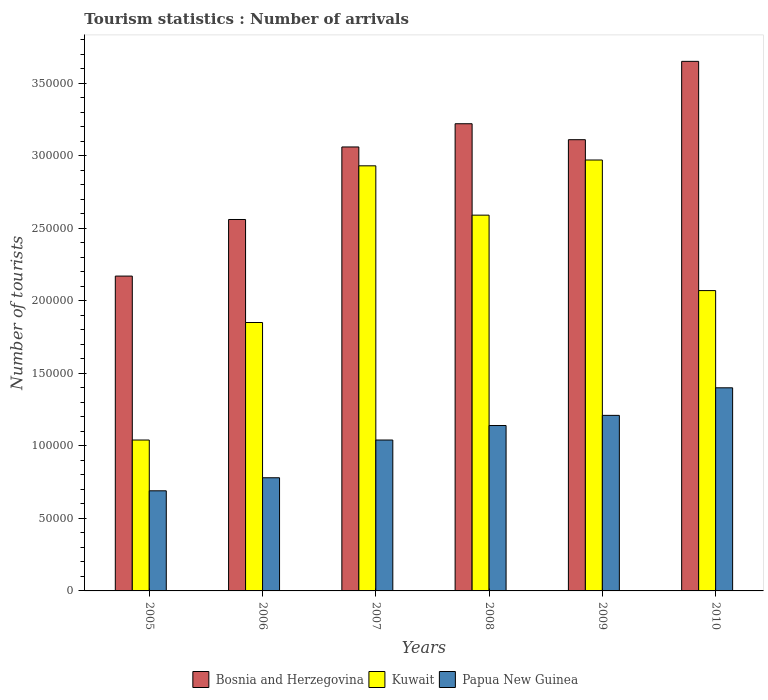How many different coloured bars are there?
Make the answer very short. 3. Are the number of bars on each tick of the X-axis equal?
Keep it short and to the point. Yes. How many bars are there on the 2nd tick from the right?
Make the answer very short. 3. What is the label of the 3rd group of bars from the left?
Ensure brevity in your answer.  2007. What is the number of tourist arrivals in Papua New Guinea in 2005?
Provide a succinct answer. 6.90e+04. Across all years, what is the maximum number of tourist arrivals in Bosnia and Herzegovina?
Offer a terse response. 3.65e+05. Across all years, what is the minimum number of tourist arrivals in Papua New Guinea?
Your answer should be very brief. 6.90e+04. In which year was the number of tourist arrivals in Kuwait maximum?
Ensure brevity in your answer.  2009. What is the total number of tourist arrivals in Kuwait in the graph?
Offer a terse response. 1.34e+06. What is the difference between the number of tourist arrivals in Bosnia and Herzegovina in 2005 and that in 2010?
Keep it short and to the point. -1.48e+05. What is the difference between the number of tourist arrivals in Papua New Guinea in 2008 and the number of tourist arrivals in Bosnia and Herzegovina in 2010?
Offer a terse response. -2.51e+05. What is the average number of tourist arrivals in Bosnia and Herzegovina per year?
Give a very brief answer. 2.96e+05. In the year 2010, what is the difference between the number of tourist arrivals in Bosnia and Herzegovina and number of tourist arrivals in Papua New Guinea?
Keep it short and to the point. 2.25e+05. In how many years, is the number of tourist arrivals in Papua New Guinea greater than 260000?
Offer a terse response. 0. What is the ratio of the number of tourist arrivals in Kuwait in 2006 to that in 2009?
Provide a succinct answer. 0.62. Is the number of tourist arrivals in Papua New Guinea in 2005 less than that in 2010?
Provide a succinct answer. Yes. What is the difference between the highest and the second highest number of tourist arrivals in Kuwait?
Make the answer very short. 4000. What is the difference between the highest and the lowest number of tourist arrivals in Papua New Guinea?
Give a very brief answer. 7.10e+04. In how many years, is the number of tourist arrivals in Papua New Guinea greater than the average number of tourist arrivals in Papua New Guinea taken over all years?
Provide a short and direct response. 3. Is the sum of the number of tourist arrivals in Papua New Guinea in 2007 and 2009 greater than the maximum number of tourist arrivals in Kuwait across all years?
Provide a short and direct response. No. What does the 3rd bar from the left in 2005 represents?
Provide a succinct answer. Papua New Guinea. What does the 2nd bar from the right in 2009 represents?
Keep it short and to the point. Kuwait. Is it the case that in every year, the sum of the number of tourist arrivals in Kuwait and number of tourist arrivals in Bosnia and Herzegovina is greater than the number of tourist arrivals in Papua New Guinea?
Offer a very short reply. Yes. Are all the bars in the graph horizontal?
Your response must be concise. No. How many years are there in the graph?
Offer a very short reply. 6. Does the graph contain any zero values?
Your answer should be compact. No. Does the graph contain grids?
Your answer should be compact. No. How many legend labels are there?
Make the answer very short. 3. How are the legend labels stacked?
Give a very brief answer. Horizontal. What is the title of the graph?
Your answer should be very brief. Tourism statistics : Number of arrivals. What is the label or title of the Y-axis?
Keep it short and to the point. Number of tourists. What is the Number of tourists in Bosnia and Herzegovina in 2005?
Ensure brevity in your answer.  2.17e+05. What is the Number of tourists of Kuwait in 2005?
Make the answer very short. 1.04e+05. What is the Number of tourists in Papua New Guinea in 2005?
Offer a very short reply. 6.90e+04. What is the Number of tourists of Bosnia and Herzegovina in 2006?
Offer a very short reply. 2.56e+05. What is the Number of tourists in Kuwait in 2006?
Offer a very short reply. 1.85e+05. What is the Number of tourists in Papua New Guinea in 2006?
Offer a very short reply. 7.80e+04. What is the Number of tourists of Bosnia and Herzegovina in 2007?
Keep it short and to the point. 3.06e+05. What is the Number of tourists of Kuwait in 2007?
Your answer should be compact. 2.93e+05. What is the Number of tourists of Papua New Guinea in 2007?
Your response must be concise. 1.04e+05. What is the Number of tourists in Bosnia and Herzegovina in 2008?
Make the answer very short. 3.22e+05. What is the Number of tourists of Kuwait in 2008?
Keep it short and to the point. 2.59e+05. What is the Number of tourists in Papua New Guinea in 2008?
Your response must be concise. 1.14e+05. What is the Number of tourists in Bosnia and Herzegovina in 2009?
Your answer should be compact. 3.11e+05. What is the Number of tourists of Kuwait in 2009?
Make the answer very short. 2.97e+05. What is the Number of tourists of Papua New Guinea in 2009?
Give a very brief answer. 1.21e+05. What is the Number of tourists in Bosnia and Herzegovina in 2010?
Ensure brevity in your answer.  3.65e+05. What is the Number of tourists in Kuwait in 2010?
Your answer should be very brief. 2.07e+05. Across all years, what is the maximum Number of tourists of Bosnia and Herzegovina?
Your answer should be compact. 3.65e+05. Across all years, what is the maximum Number of tourists in Kuwait?
Offer a very short reply. 2.97e+05. Across all years, what is the minimum Number of tourists of Bosnia and Herzegovina?
Your answer should be very brief. 2.17e+05. Across all years, what is the minimum Number of tourists of Kuwait?
Your response must be concise. 1.04e+05. Across all years, what is the minimum Number of tourists of Papua New Guinea?
Keep it short and to the point. 6.90e+04. What is the total Number of tourists in Bosnia and Herzegovina in the graph?
Offer a very short reply. 1.78e+06. What is the total Number of tourists of Kuwait in the graph?
Your answer should be very brief. 1.34e+06. What is the total Number of tourists in Papua New Guinea in the graph?
Make the answer very short. 6.26e+05. What is the difference between the Number of tourists of Bosnia and Herzegovina in 2005 and that in 2006?
Offer a terse response. -3.90e+04. What is the difference between the Number of tourists in Kuwait in 2005 and that in 2006?
Keep it short and to the point. -8.10e+04. What is the difference between the Number of tourists of Papua New Guinea in 2005 and that in 2006?
Give a very brief answer. -9000. What is the difference between the Number of tourists in Bosnia and Herzegovina in 2005 and that in 2007?
Ensure brevity in your answer.  -8.90e+04. What is the difference between the Number of tourists of Kuwait in 2005 and that in 2007?
Provide a short and direct response. -1.89e+05. What is the difference between the Number of tourists of Papua New Guinea in 2005 and that in 2007?
Ensure brevity in your answer.  -3.50e+04. What is the difference between the Number of tourists in Bosnia and Herzegovina in 2005 and that in 2008?
Provide a short and direct response. -1.05e+05. What is the difference between the Number of tourists of Kuwait in 2005 and that in 2008?
Give a very brief answer. -1.55e+05. What is the difference between the Number of tourists of Papua New Guinea in 2005 and that in 2008?
Offer a very short reply. -4.50e+04. What is the difference between the Number of tourists of Bosnia and Herzegovina in 2005 and that in 2009?
Ensure brevity in your answer.  -9.40e+04. What is the difference between the Number of tourists of Kuwait in 2005 and that in 2009?
Provide a succinct answer. -1.93e+05. What is the difference between the Number of tourists in Papua New Guinea in 2005 and that in 2009?
Give a very brief answer. -5.20e+04. What is the difference between the Number of tourists of Bosnia and Herzegovina in 2005 and that in 2010?
Your response must be concise. -1.48e+05. What is the difference between the Number of tourists in Kuwait in 2005 and that in 2010?
Keep it short and to the point. -1.03e+05. What is the difference between the Number of tourists in Papua New Guinea in 2005 and that in 2010?
Your response must be concise. -7.10e+04. What is the difference between the Number of tourists of Kuwait in 2006 and that in 2007?
Offer a terse response. -1.08e+05. What is the difference between the Number of tourists of Papua New Guinea in 2006 and that in 2007?
Make the answer very short. -2.60e+04. What is the difference between the Number of tourists of Bosnia and Herzegovina in 2006 and that in 2008?
Provide a succinct answer. -6.60e+04. What is the difference between the Number of tourists in Kuwait in 2006 and that in 2008?
Offer a very short reply. -7.40e+04. What is the difference between the Number of tourists in Papua New Guinea in 2006 and that in 2008?
Give a very brief answer. -3.60e+04. What is the difference between the Number of tourists of Bosnia and Herzegovina in 2006 and that in 2009?
Your response must be concise. -5.50e+04. What is the difference between the Number of tourists in Kuwait in 2006 and that in 2009?
Offer a very short reply. -1.12e+05. What is the difference between the Number of tourists of Papua New Guinea in 2006 and that in 2009?
Your response must be concise. -4.30e+04. What is the difference between the Number of tourists of Bosnia and Herzegovina in 2006 and that in 2010?
Give a very brief answer. -1.09e+05. What is the difference between the Number of tourists in Kuwait in 2006 and that in 2010?
Ensure brevity in your answer.  -2.20e+04. What is the difference between the Number of tourists in Papua New Guinea in 2006 and that in 2010?
Keep it short and to the point. -6.20e+04. What is the difference between the Number of tourists of Bosnia and Herzegovina in 2007 and that in 2008?
Ensure brevity in your answer.  -1.60e+04. What is the difference between the Number of tourists of Kuwait in 2007 and that in 2008?
Make the answer very short. 3.40e+04. What is the difference between the Number of tourists in Papua New Guinea in 2007 and that in 2008?
Your response must be concise. -10000. What is the difference between the Number of tourists of Bosnia and Herzegovina in 2007 and that in 2009?
Make the answer very short. -5000. What is the difference between the Number of tourists of Kuwait in 2007 and that in 2009?
Your response must be concise. -4000. What is the difference between the Number of tourists in Papua New Guinea in 2007 and that in 2009?
Offer a terse response. -1.70e+04. What is the difference between the Number of tourists of Bosnia and Herzegovina in 2007 and that in 2010?
Your answer should be compact. -5.90e+04. What is the difference between the Number of tourists in Kuwait in 2007 and that in 2010?
Make the answer very short. 8.60e+04. What is the difference between the Number of tourists in Papua New Guinea in 2007 and that in 2010?
Offer a very short reply. -3.60e+04. What is the difference between the Number of tourists in Bosnia and Herzegovina in 2008 and that in 2009?
Your answer should be very brief. 1.10e+04. What is the difference between the Number of tourists of Kuwait in 2008 and that in 2009?
Ensure brevity in your answer.  -3.80e+04. What is the difference between the Number of tourists in Papua New Guinea in 2008 and that in 2009?
Offer a terse response. -7000. What is the difference between the Number of tourists of Bosnia and Herzegovina in 2008 and that in 2010?
Your response must be concise. -4.30e+04. What is the difference between the Number of tourists of Kuwait in 2008 and that in 2010?
Provide a short and direct response. 5.20e+04. What is the difference between the Number of tourists of Papua New Guinea in 2008 and that in 2010?
Keep it short and to the point. -2.60e+04. What is the difference between the Number of tourists of Bosnia and Herzegovina in 2009 and that in 2010?
Your response must be concise. -5.40e+04. What is the difference between the Number of tourists in Kuwait in 2009 and that in 2010?
Give a very brief answer. 9.00e+04. What is the difference between the Number of tourists in Papua New Guinea in 2009 and that in 2010?
Make the answer very short. -1.90e+04. What is the difference between the Number of tourists in Bosnia and Herzegovina in 2005 and the Number of tourists in Kuwait in 2006?
Your response must be concise. 3.20e+04. What is the difference between the Number of tourists of Bosnia and Herzegovina in 2005 and the Number of tourists of Papua New Guinea in 2006?
Provide a succinct answer. 1.39e+05. What is the difference between the Number of tourists in Kuwait in 2005 and the Number of tourists in Papua New Guinea in 2006?
Your answer should be very brief. 2.60e+04. What is the difference between the Number of tourists of Bosnia and Herzegovina in 2005 and the Number of tourists of Kuwait in 2007?
Ensure brevity in your answer.  -7.60e+04. What is the difference between the Number of tourists of Bosnia and Herzegovina in 2005 and the Number of tourists of Papua New Guinea in 2007?
Offer a terse response. 1.13e+05. What is the difference between the Number of tourists in Bosnia and Herzegovina in 2005 and the Number of tourists in Kuwait in 2008?
Keep it short and to the point. -4.20e+04. What is the difference between the Number of tourists in Bosnia and Herzegovina in 2005 and the Number of tourists in Papua New Guinea in 2008?
Your answer should be very brief. 1.03e+05. What is the difference between the Number of tourists in Kuwait in 2005 and the Number of tourists in Papua New Guinea in 2008?
Your answer should be very brief. -10000. What is the difference between the Number of tourists of Bosnia and Herzegovina in 2005 and the Number of tourists of Papua New Guinea in 2009?
Your answer should be compact. 9.60e+04. What is the difference between the Number of tourists in Kuwait in 2005 and the Number of tourists in Papua New Guinea in 2009?
Your answer should be very brief. -1.70e+04. What is the difference between the Number of tourists in Bosnia and Herzegovina in 2005 and the Number of tourists in Kuwait in 2010?
Your answer should be very brief. 10000. What is the difference between the Number of tourists in Bosnia and Herzegovina in 2005 and the Number of tourists in Papua New Guinea in 2010?
Your response must be concise. 7.70e+04. What is the difference between the Number of tourists in Kuwait in 2005 and the Number of tourists in Papua New Guinea in 2010?
Your answer should be very brief. -3.60e+04. What is the difference between the Number of tourists of Bosnia and Herzegovina in 2006 and the Number of tourists of Kuwait in 2007?
Provide a short and direct response. -3.70e+04. What is the difference between the Number of tourists of Bosnia and Herzegovina in 2006 and the Number of tourists of Papua New Guinea in 2007?
Offer a terse response. 1.52e+05. What is the difference between the Number of tourists in Kuwait in 2006 and the Number of tourists in Papua New Guinea in 2007?
Your response must be concise. 8.10e+04. What is the difference between the Number of tourists in Bosnia and Herzegovina in 2006 and the Number of tourists in Kuwait in 2008?
Your answer should be very brief. -3000. What is the difference between the Number of tourists of Bosnia and Herzegovina in 2006 and the Number of tourists of Papua New Guinea in 2008?
Make the answer very short. 1.42e+05. What is the difference between the Number of tourists in Kuwait in 2006 and the Number of tourists in Papua New Guinea in 2008?
Give a very brief answer. 7.10e+04. What is the difference between the Number of tourists in Bosnia and Herzegovina in 2006 and the Number of tourists in Kuwait in 2009?
Keep it short and to the point. -4.10e+04. What is the difference between the Number of tourists of Bosnia and Herzegovina in 2006 and the Number of tourists of Papua New Guinea in 2009?
Give a very brief answer. 1.35e+05. What is the difference between the Number of tourists in Kuwait in 2006 and the Number of tourists in Papua New Guinea in 2009?
Offer a very short reply. 6.40e+04. What is the difference between the Number of tourists in Bosnia and Herzegovina in 2006 and the Number of tourists in Kuwait in 2010?
Your response must be concise. 4.90e+04. What is the difference between the Number of tourists in Bosnia and Herzegovina in 2006 and the Number of tourists in Papua New Guinea in 2010?
Provide a succinct answer. 1.16e+05. What is the difference between the Number of tourists in Kuwait in 2006 and the Number of tourists in Papua New Guinea in 2010?
Give a very brief answer. 4.50e+04. What is the difference between the Number of tourists in Bosnia and Herzegovina in 2007 and the Number of tourists in Kuwait in 2008?
Keep it short and to the point. 4.70e+04. What is the difference between the Number of tourists in Bosnia and Herzegovina in 2007 and the Number of tourists in Papua New Guinea in 2008?
Keep it short and to the point. 1.92e+05. What is the difference between the Number of tourists of Kuwait in 2007 and the Number of tourists of Papua New Guinea in 2008?
Your response must be concise. 1.79e+05. What is the difference between the Number of tourists in Bosnia and Herzegovina in 2007 and the Number of tourists in Kuwait in 2009?
Offer a very short reply. 9000. What is the difference between the Number of tourists in Bosnia and Herzegovina in 2007 and the Number of tourists in Papua New Guinea in 2009?
Your answer should be very brief. 1.85e+05. What is the difference between the Number of tourists in Kuwait in 2007 and the Number of tourists in Papua New Guinea in 2009?
Give a very brief answer. 1.72e+05. What is the difference between the Number of tourists in Bosnia and Herzegovina in 2007 and the Number of tourists in Kuwait in 2010?
Offer a very short reply. 9.90e+04. What is the difference between the Number of tourists of Bosnia and Herzegovina in 2007 and the Number of tourists of Papua New Guinea in 2010?
Provide a succinct answer. 1.66e+05. What is the difference between the Number of tourists in Kuwait in 2007 and the Number of tourists in Papua New Guinea in 2010?
Ensure brevity in your answer.  1.53e+05. What is the difference between the Number of tourists in Bosnia and Herzegovina in 2008 and the Number of tourists in Kuwait in 2009?
Ensure brevity in your answer.  2.50e+04. What is the difference between the Number of tourists of Bosnia and Herzegovina in 2008 and the Number of tourists of Papua New Guinea in 2009?
Give a very brief answer. 2.01e+05. What is the difference between the Number of tourists of Kuwait in 2008 and the Number of tourists of Papua New Guinea in 2009?
Your answer should be very brief. 1.38e+05. What is the difference between the Number of tourists in Bosnia and Herzegovina in 2008 and the Number of tourists in Kuwait in 2010?
Ensure brevity in your answer.  1.15e+05. What is the difference between the Number of tourists of Bosnia and Herzegovina in 2008 and the Number of tourists of Papua New Guinea in 2010?
Give a very brief answer. 1.82e+05. What is the difference between the Number of tourists in Kuwait in 2008 and the Number of tourists in Papua New Guinea in 2010?
Ensure brevity in your answer.  1.19e+05. What is the difference between the Number of tourists of Bosnia and Herzegovina in 2009 and the Number of tourists of Kuwait in 2010?
Provide a succinct answer. 1.04e+05. What is the difference between the Number of tourists of Bosnia and Herzegovina in 2009 and the Number of tourists of Papua New Guinea in 2010?
Your answer should be very brief. 1.71e+05. What is the difference between the Number of tourists in Kuwait in 2009 and the Number of tourists in Papua New Guinea in 2010?
Ensure brevity in your answer.  1.57e+05. What is the average Number of tourists of Bosnia and Herzegovina per year?
Your response must be concise. 2.96e+05. What is the average Number of tourists in Kuwait per year?
Your response must be concise. 2.24e+05. What is the average Number of tourists of Papua New Guinea per year?
Your answer should be very brief. 1.04e+05. In the year 2005, what is the difference between the Number of tourists in Bosnia and Herzegovina and Number of tourists in Kuwait?
Provide a succinct answer. 1.13e+05. In the year 2005, what is the difference between the Number of tourists in Bosnia and Herzegovina and Number of tourists in Papua New Guinea?
Your answer should be compact. 1.48e+05. In the year 2005, what is the difference between the Number of tourists in Kuwait and Number of tourists in Papua New Guinea?
Provide a succinct answer. 3.50e+04. In the year 2006, what is the difference between the Number of tourists of Bosnia and Herzegovina and Number of tourists of Kuwait?
Ensure brevity in your answer.  7.10e+04. In the year 2006, what is the difference between the Number of tourists in Bosnia and Herzegovina and Number of tourists in Papua New Guinea?
Give a very brief answer. 1.78e+05. In the year 2006, what is the difference between the Number of tourists in Kuwait and Number of tourists in Papua New Guinea?
Provide a succinct answer. 1.07e+05. In the year 2007, what is the difference between the Number of tourists in Bosnia and Herzegovina and Number of tourists in Kuwait?
Provide a succinct answer. 1.30e+04. In the year 2007, what is the difference between the Number of tourists in Bosnia and Herzegovina and Number of tourists in Papua New Guinea?
Provide a succinct answer. 2.02e+05. In the year 2007, what is the difference between the Number of tourists in Kuwait and Number of tourists in Papua New Guinea?
Offer a very short reply. 1.89e+05. In the year 2008, what is the difference between the Number of tourists in Bosnia and Herzegovina and Number of tourists in Kuwait?
Your response must be concise. 6.30e+04. In the year 2008, what is the difference between the Number of tourists of Bosnia and Herzegovina and Number of tourists of Papua New Guinea?
Offer a very short reply. 2.08e+05. In the year 2008, what is the difference between the Number of tourists of Kuwait and Number of tourists of Papua New Guinea?
Give a very brief answer. 1.45e+05. In the year 2009, what is the difference between the Number of tourists in Bosnia and Herzegovina and Number of tourists in Kuwait?
Give a very brief answer. 1.40e+04. In the year 2009, what is the difference between the Number of tourists in Bosnia and Herzegovina and Number of tourists in Papua New Guinea?
Provide a succinct answer. 1.90e+05. In the year 2009, what is the difference between the Number of tourists of Kuwait and Number of tourists of Papua New Guinea?
Offer a very short reply. 1.76e+05. In the year 2010, what is the difference between the Number of tourists of Bosnia and Herzegovina and Number of tourists of Kuwait?
Give a very brief answer. 1.58e+05. In the year 2010, what is the difference between the Number of tourists of Bosnia and Herzegovina and Number of tourists of Papua New Guinea?
Make the answer very short. 2.25e+05. In the year 2010, what is the difference between the Number of tourists in Kuwait and Number of tourists in Papua New Guinea?
Ensure brevity in your answer.  6.70e+04. What is the ratio of the Number of tourists of Bosnia and Herzegovina in 2005 to that in 2006?
Keep it short and to the point. 0.85. What is the ratio of the Number of tourists in Kuwait in 2005 to that in 2006?
Provide a succinct answer. 0.56. What is the ratio of the Number of tourists of Papua New Guinea in 2005 to that in 2006?
Ensure brevity in your answer.  0.88. What is the ratio of the Number of tourists in Bosnia and Herzegovina in 2005 to that in 2007?
Your response must be concise. 0.71. What is the ratio of the Number of tourists in Kuwait in 2005 to that in 2007?
Your response must be concise. 0.35. What is the ratio of the Number of tourists of Papua New Guinea in 2005 to that in 2007?
Provide a short and direct response. 0.66. What is the ratio of the Number of tourists of Bosnia and Herzegovina in 2005 to that in 2008?
Make the answer very short. 0.67. What is the ratio of the Number of tourists in Kuwait in 2005 to that in 2008?
Offer a terse response. 0.4. What is the ratio of the Number of tourists of Papua New Guinea in 2005 to that in 2008?
Your answer should be very brief. 0.61. What is the ratio of the Number of tourists in Bosnia and Herzegovina in 2005 to that in 2009?
Make the answer very short. 0.7. What is the ratio of the Number of tourists in Kuwait in 2005 to that in 2009?
Offer a terse response. 0.35. What is the ratio of the Number of tourists of Papua New Guinea in 2005 to that in 2009?
Provide a short and direct response. 0.57. What is the ratio of the Number of tourists in Bosnia and Herzegovina in 2005 to that in 2010?
Provide a short and direct response. 0.59. What is the ratio of the Number of tourists of Kuwait in 2005 to that in 2010?
Your response must be concise. 0.5. What is the ratio of the Number of tourists in Papua New Guinea in 2005 to that in 2010?
Provide a short and direct response. 0.49. What is the ratio of the Number of tourists of Bosnia and Herzegovina in 2006 to that in 2007?
Provide a succinct answer. 0.84. What is the ratio of the Number of tourists in Kuwait in 2006 to that in 2007?
Provide a succinct answer. 0.63. What is the ratio of the Number of tourists in Papua New Guinea in 2006 to that in 2007?
Offer a very short reply. 0.75. What is the ratio of the Number of tourists in Bosnia and Herzegovina in 2006 to that in 2008?
Offer a very short reply. 0.8. What is the ratio of the Number of tourists of Papua New Guinea in 2006 to that in 2008?
Give a very brief answer. 0.68. What is the ratio of the Number of tourists of Bosnia and Herzegovina in 2006 to that in 2009?
Your answer should be compact. 0.82. What is the ratio of the Number of tourists in Kuwait in 2006 to that in 2009?
Offer a terse response. 0.62. What is the ratio of the Number of tourists in Papua New Guinea in 2006 to that in 2009?
Your response must be concise. 0.64. What is the ratio of the Number of tourists in Bosnia and Herzegovina in 2006 to that in 2010?
Offer a terse response. 0.7. What is the ratio of the Number of tourists in Kuwait in 2006 to that in 2010?
Provide a short and direct response. 0.89. What is the ratio of the Number of tourists of Papua New Guinea in 2006 to that in 2010?
Your response must be concise. 0.56. What is the ratio of the Number of tourists in Bosnia and Herzegovina in 2007 to that in 2008?
Ensure brevity in your answer.  0.95. What is the ratio of the Number of tourists of Kuwait in 2007 to that in 2008?
Ensure brevity in your answer.  1.13. What is the ratio of the Number of tourists of Papua New Guinea in 2007 to that in 2008?
Provide a succinct answer. 0.91. What is the ratio of the Number of tourists in Bosnia and Herzegovina in 2007 to that in 2009?
Provide a short and direct response. 0.98. What is the ratio of the Number of tourists in Kuwait in 2007 to that in 2009?
Your response must be concise. 0.99. What is the ratio of the Number of tourists in Papua New Guinea in 2007 to that in 2009?
Your answer should be compact. 0.86. What is the ratio of the Number of tourists in Bosnia and Herzegovina in 2007 to that in 2010?
Keep it short and to the point. 0.84. What is the ratio of the Number of tourists in Kuwait in 2007 to that in 2010?
Make the answer very short. 1.42. What is the ratio of the Number of tourists of Papua New Guinea in 2007 to that in 2010?
Give a very brief answer. 0.74. What is the ratio of the Number of tourists in Bosnia and Herzegovina in 2008 to that in 2009?
Provide a short and direct response. 1.04. What is the ratio of the Number of tourists in Kuwait in 2008 to that in 2009?
Your response must be concise. 0.87. What is the ratio of the Number of tourists of Papua New Guinea in 2008 to that in 2009?
Provide a short and direct response. 0.94. What is the ratio of the Number of tourists in Bosnia and Herzegovina in 2008 to that in 2010?
Provide a succinct answer. 0.88. What is the ratio of the Number of tourists of Kuwait in 2008 to that in 2010?
Ensure brevity in your answer.  1.25. What is the ratio of the Number of tourists of Papua New Guinea in 2008 to that in 2010?
Offer a terse response. 0.81. What is the ratio of the Number of tourists in Bosnia and Herzegovina in 2009 to that in 2010?
Offer a terse response. 0.85. What is the ratio of the Number of tourists in Kuwait in 2009 to that in 2010?
Provide a short and direct response. 1.43. What is the ratio of the Number of tourists in Papua New Guinea in 2009 to that in 2010?
Keep it short and to the point. 0.86. What is the difference between the highest and the second highest Number of tourists in Bosnia and Herzegovina?
Make the answer very short. 4.30e+04. What is the difference between the highest and the second highest Number of tourists of Kuwait?
Provide a short and direct response. 4000. What is the difference between the highest and the second highest Number of tourists of Papua New Guinea?
Provide a short and direct response. 1.90e+04. What is the difference between the highest and the lowest Number of tourists of Bosnia and Herzegovina?
Ensure brevity in your answer.  1.48e+05. What is the difference between the highest and the lowest Number of tourists of Kuwait?
Give a very brief answer. 1.93e+05. What is the difference between the highest and the lowest Number of tourists in Papua New Guinea?
Your response must be concise. 7.10e+04. 